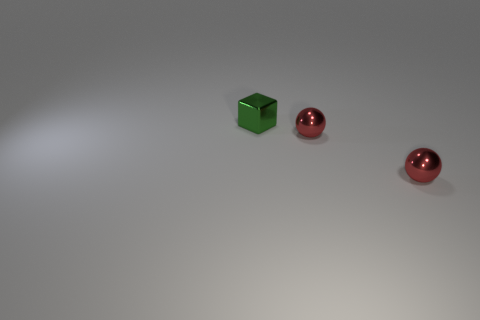Add 2 green metallic things. How many objects exist? 5 Subtract all balls. How many objects are left? 1 Add 1 red metallic spheres. How many red metallic spheres exist? 3 Subtract 0 purple blocks. How many objects are left? 3 Subtract all small red things. Subtract all small shiny cubes. How many objects are left? 0 Add 3 metallic balls. How many metallic balls are left? 5 